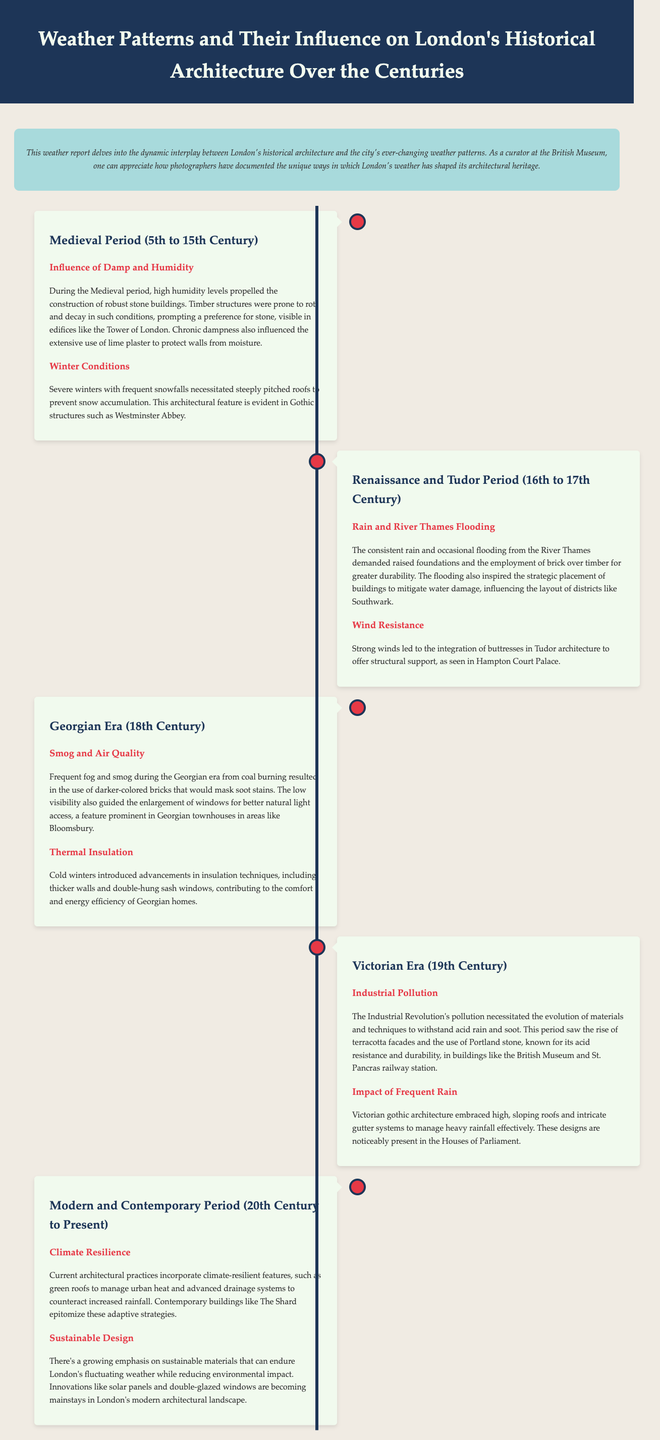What architectural feature was influenced by severe winters in the Medieval period? The document mentions steeply pitched roofs were necessary to prevent snow accumulation, which is an architectural feature noted in Gothic structures.
Answer: Steeply pitched roofs Which material became preferred during the Renaissance and Tudor periods due to flooding? The report states that brick was employed over timber for greater durability in response to consistent rain and flooding from the River Thames.
Answer: Brick What significant pollution type affected architecture during the Victorian Era? The document explicitly refers to industrial pollution necessitating the evolution of materials to withstand acid rain and soot, influencing building materials.
Answer: Industrial pollution How did Georgian architects respond to low visibility conditions? The enlargement of windows was a design response to frequent fog and smog, aimed at improving natural light access.
Answer: Enlargement of windows What is one climate-resilient feature incorporated in contemporary architecture? The text specifies that green roofs are currently implemented in architectural practices to manage urban heat as a climate-resilient feature.
Answer: Green roofs What was a major influence on the construction of stone buildings during the Medieval period? The document indicates that high humidity levels were a major influence prompting the construction of robust stone buildings instead of timber structures.
Answer: High humidity levels During which period did the use of darker-colored bricks become prominent? The report notes that during the Georgian Era, darker-colored bricks were used to mask soot stains from coal burning.
Answer: Georgian Era What type of roof design became prominent during the Victorian Era? The document highlights high, sloping roofs as a feature embraced in Victorian gothic architecture to manage heavy rainfall effectively.
Answer: High, sloping roofs What architectural trend is emphasized in modern buildings in London? The document discusses a growing emphasis on sustainable materials that can endure London’s fluctuating weather and reduce environmental impact.
Answer: Sustainable materials 